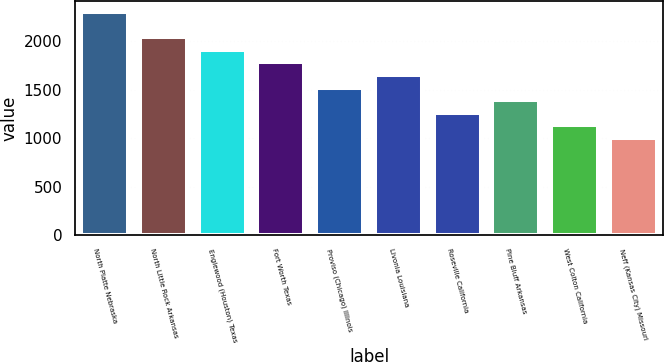Convert chart to OTSL. <chart><loc_0><loc_0><loc_500><loc_500><bar_chart><fcel>North Platte Nebraska<fcel>North Little Rock Arkansas<fcel>Englewood (Houston) Texas<fcel>Fort Worth Texas<fcel>Proviso (Chicago) Illinois<fcel>Livonia Louisiana<fcel>Roseville California<fcel>Pine Bluff Arkansas<fcel>West Colton California<fcel>Neff (Kansas City) Missouri<nl><fcel>2300<fcel>2040<fcel>1910<fcel>1780<fcel>1520<fcel>1650<fcel>1260<fcel>1390<fcel>1130<fcel>1000<nl></chart> 